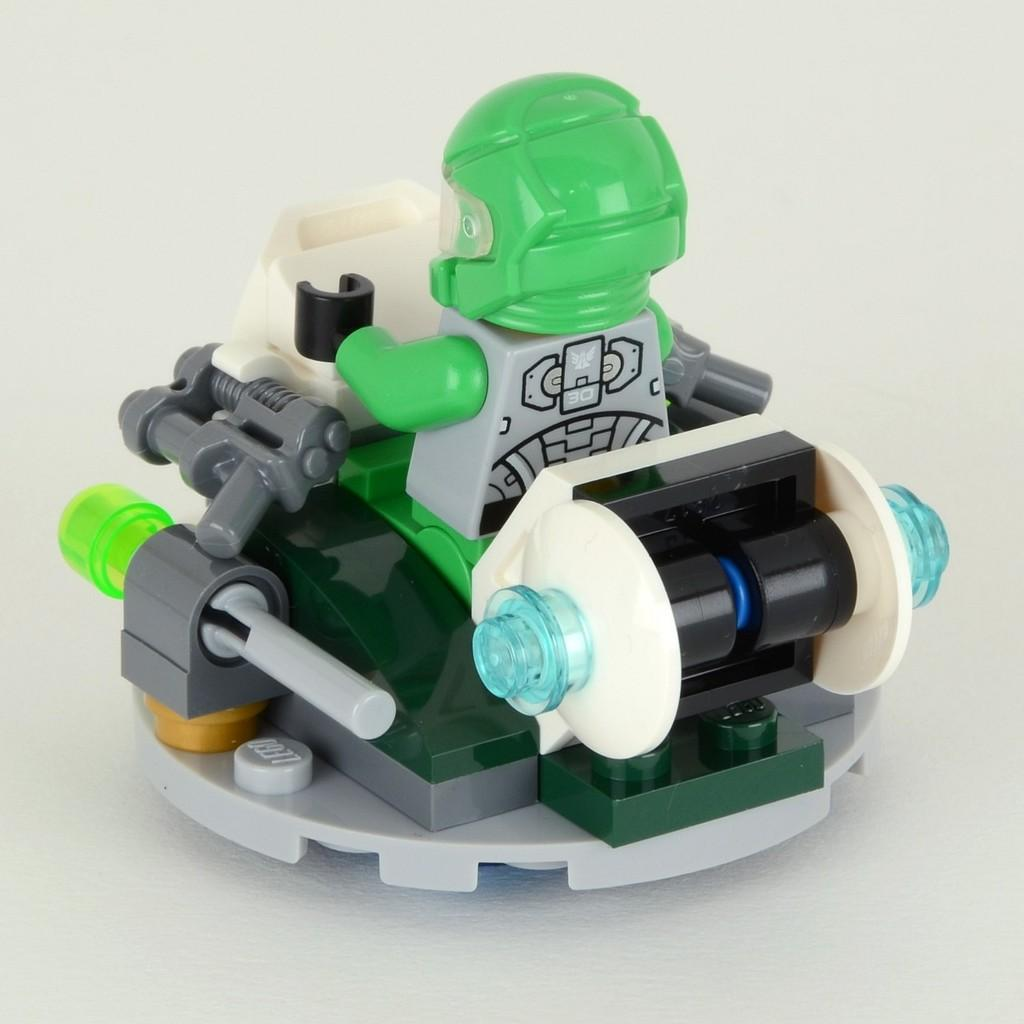What object can be seen in the image? There is a toy in the image. What is the color of the surface on which the toy is placed? The toy is on a white surface. What type of smell can be detected from the toy in the image? There is no information about the smell of the toy in the image, as it is a visual representation. 